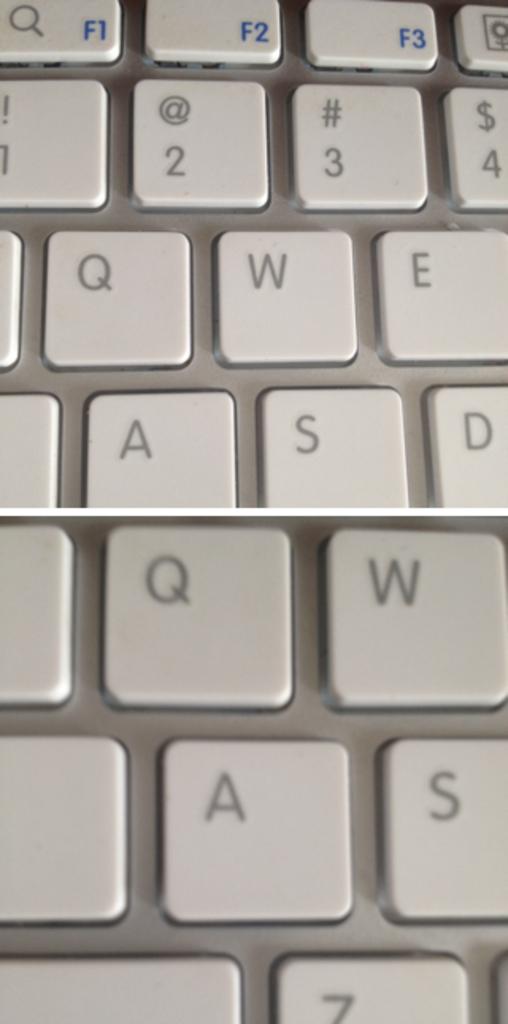What letter is at the bottom?
Your answer should be very brief. Z. 